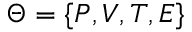<formula> <loc_0><loc_0><loc_500><loc_500>\Theta = \{ P , V , T , E \}</formula> 